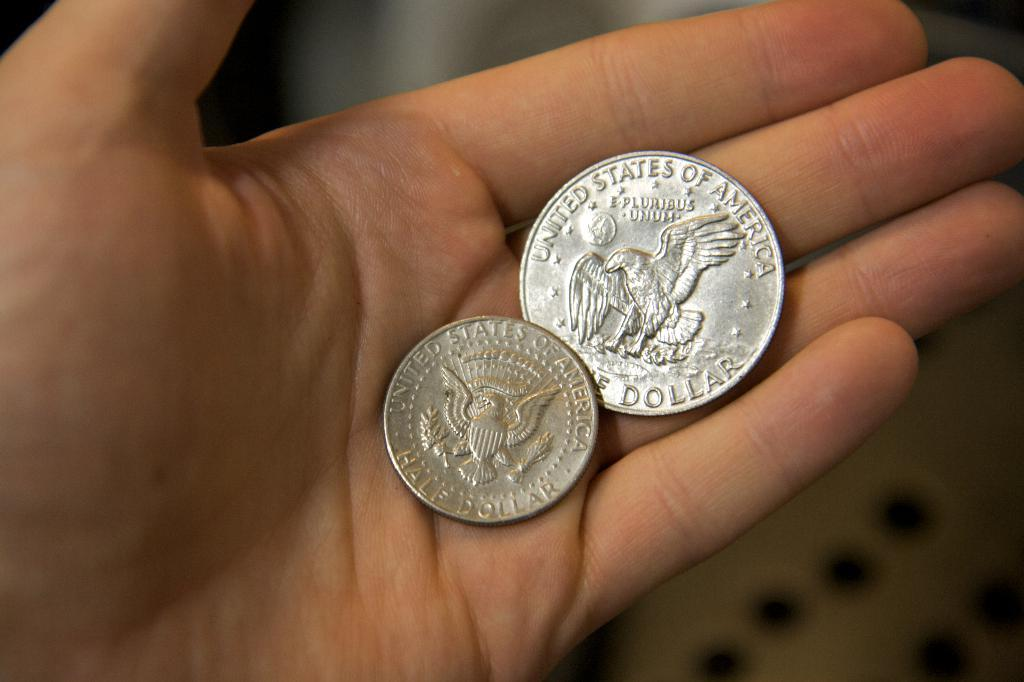<image>
Provide a brief description of the given image. Someone is holding two coins from the United States of America, including a half dollar. 